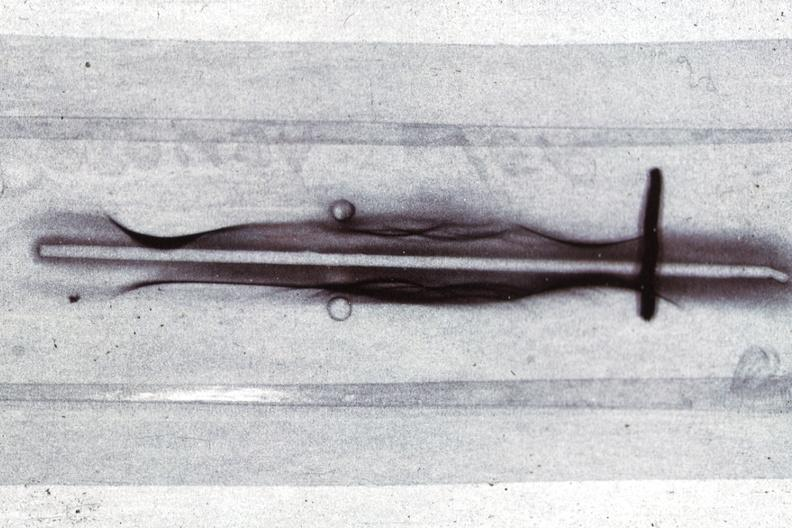s hematologic present?
Answer the question using a single word or phrase. Yes 